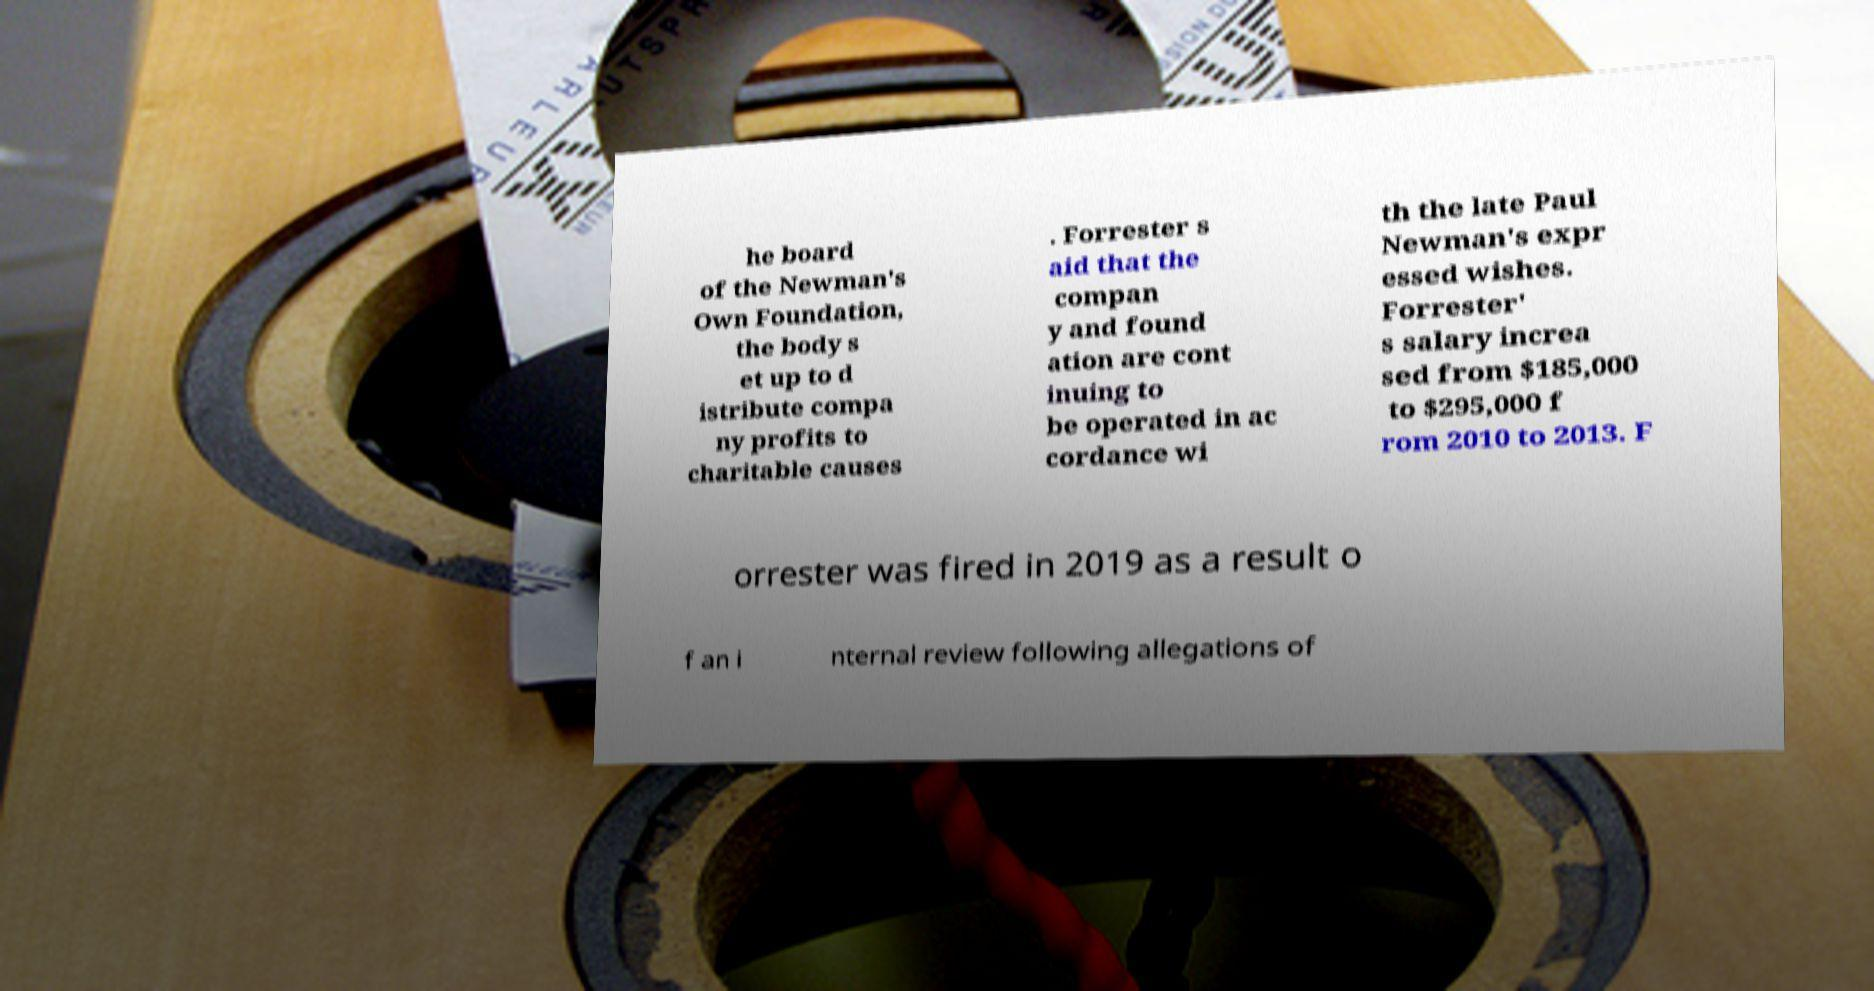Can you accurately transcribe the text from the provided image for me? he board of the Newman's Own Foundation, the body s et up to d istribute compa ny profits to charitable causes . Forrester s aid that the compan y and found ation are cont inuing to be operated in ac cordance wi th the late Paul Newman's expr essed wishes. Forrester' s salary increa sed from $185,000 to $295,000 f rom 2010 to 2013. F orrester was fired in 2019 as a result o f an i nternal review following allegations of 